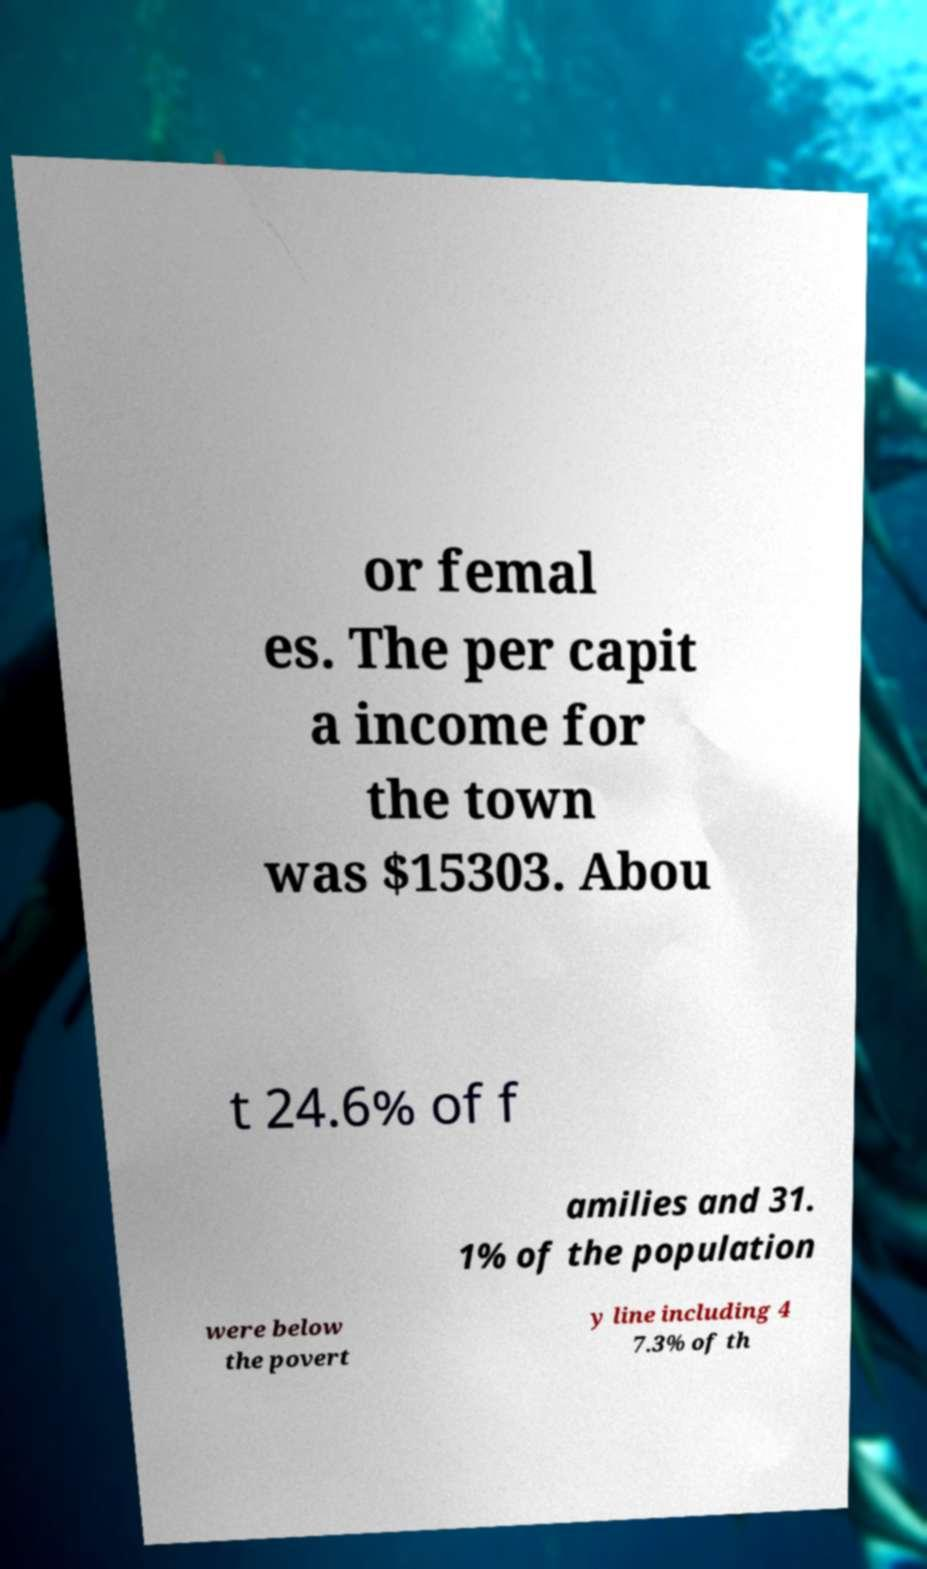Can you read and provide the text displayed in the image?This photo seems to have some interesting text. Can you extract and type it out for me? or femal es. The per capit a income for the town was $15303. Abou t 24.6% of f amilies and 31. 1% of the population were below the povert y line including 4 7.3% of th 